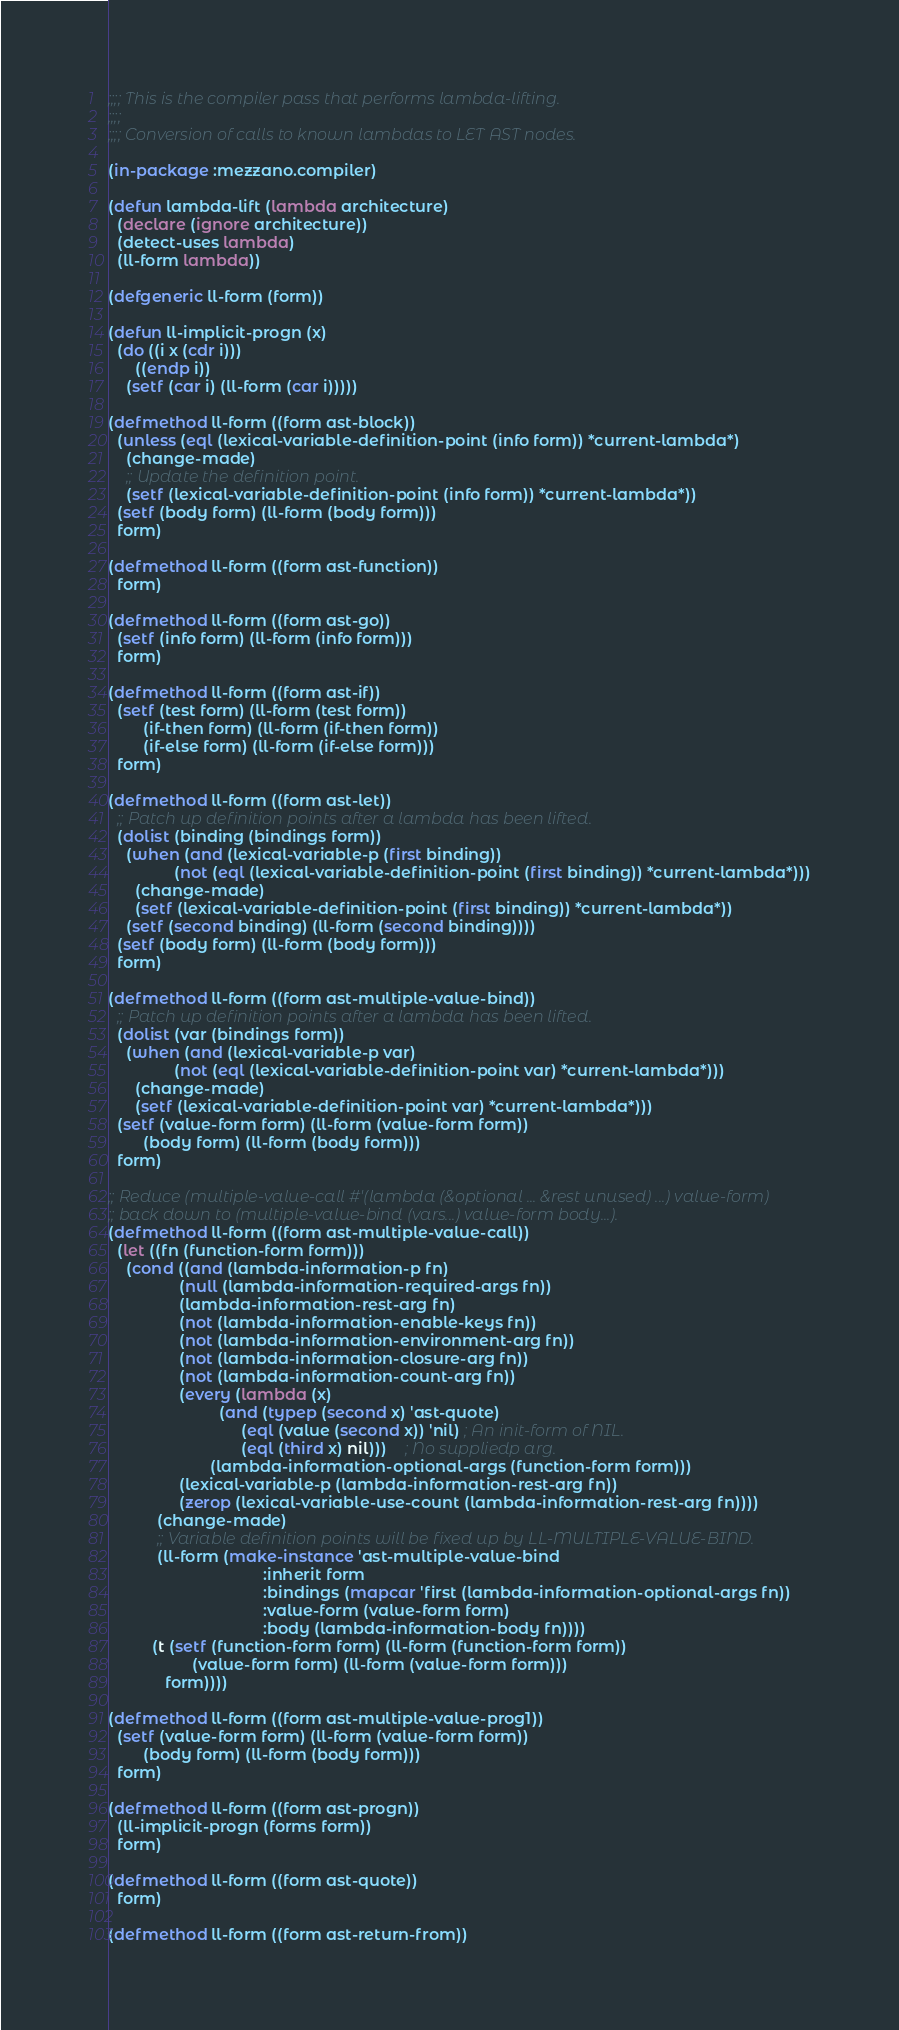<code> <loc_0><loc_0><loc_500><loc_500><_Lisp_>;;;; This is the compiler pass that performs lambda-lifting.
;;;;
;;;; Conversion of calls to known lambdas to LET AST nodes.

(in-package :mezzano.compiler)

(defun lambda-lift (lambda architecture)
  (declare (ignore architecture))
  (detect-uses lambda)
  (ll-form lambda))

(defgeneric ll-form (form))

(defun ll-implicit-progn (x)
  (do ((i x (cdr i)))
      ((endp i))
    (setf (car i) (ll-form (car i)))))

(defmethod ll-form ((form ast-block))
  (unless (eql (lexical-variable-definition-point (info form)) *current-lambda*)
    (change-made)
    ;; Update the definition point.
    (setf (lexical-variable-definition-point (info form)) *current-lambda*))
  (setf (body form) (ll-form (body form)))
  form)

(defmethod ll-form ((form ast-function))
  form)

(defmethod ll-form ((form ast-go))
  (setf (info form) (ll-form (info form)))
  form)

(defmethod ll-form ((form ast-if))
  (setf (test form) (ll-form (test form))
        (if-then form) (ll-form (if-then form))
        (if-else form) (ll-form (if-else form)))
  form)

(defmethod ll-form ((form ast-let))
  ;; Patch up definition points after a lambda has been lifted.
  (dolist (binding (bindings form))
    (when (and (lexical-variable-p (first binding))
               (not (eql (lexical-variable-definition-point (first binding)) *current-lambda*)))
      (change-made)
      (setf (lexical-variable-definition-point (first binding)) *current-lambda*))
    (setf (second binding) (ll-form (second binding))))
  (setf (body form) (ll-form (body form)))
  form)

(defmethod ll-form ((form ast-multiple-value-bind))
  ;; Patch up definition points after a lambda has been lifted.
  (dolist (var (bindings form))
    (when (and (lexical-variable-p var)
               (not (eql (lexical-variable-definition-point var) *current-lambda*)))
      (change-made)
      (setf (lexical-variable-definition-point var) *current-lambda*)))
  (setf (value-form form) (ll-form (value-form form))
        (body form) (ll-form (body form)))
  form)

;; Reduce (multiple-value-call #'(lambda (&optional ... &rest unused) ...) value-form)
;; back down to (multiple-value-bind (vars...) value-form body...).
(defmethod ll-form ((form ast-multiple-value-call))
  (let ((fn (function-form form)))
    (cond ((and (lambda-information-p fn)
                (null (lambda-information-required-args fn))
                (lambda-information-rest-arg fn)
                (not (lambda-information-enable-keys fn))
                (not (lambda-information-environment-arg fn))
                (not (lambda-information-closure-arg fn))
                (not (lambda-information-count-arg fn))
                (every (lambda (x)
                         (and (typep (second x) 'ast-quote)
                              (eql (value (second x)) 'nil) ; An init-form of NIL.
                              (eql (third x) nil)))    ; No suppliedp arg.
                       (lambda-information-optional-args (function-form form)))
                (lexical-variable-p (lambda-information-rest-arg fn))
                (zerop (lexical-variable-use-count (lambda-information-rest-arg fn))))
           (change-made)
           ;; Variable definition points will be fixed up by LL-MULTIPLE-VALUE-BIND.
           (ll-form (make-instance 'ast-multiple-value-bind
                                   :inherit form
                                   :bindings (mapcar 'first (lambda-information-optional-args fn))
                                   :value-form (value-form form)
                                   :body (lambda-information-body fn))))
          (t (setf (function-form form) (ll-form (function-form form))
                   (value-form form) (ll-form (value-form form)))
             form))))

(defmethod ll-form ((form ast-multiple-value-prog1))
  (setf (value-form form) (ll-form (value-form form))
        (body form) (ll-form (body form)))
  form)

(defmethod ll-form ((form ast-progn))
  (ll-implicit-progn (forms form))
  form)

(defmethod ll-form ((form ast-quote))
  form)

(defmethod ll-form ((form ast-return-from))</code> 